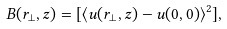<formula> <loc_0><loc_0><loc_500><loc_500>B ( { r _ { \perp } } , z ) = [ \langle { u } ( { r } _ { \perp } , z ) - { u } ( { 0 } , 0 ) \rangle ^ { 2 } ] ,</formula> 